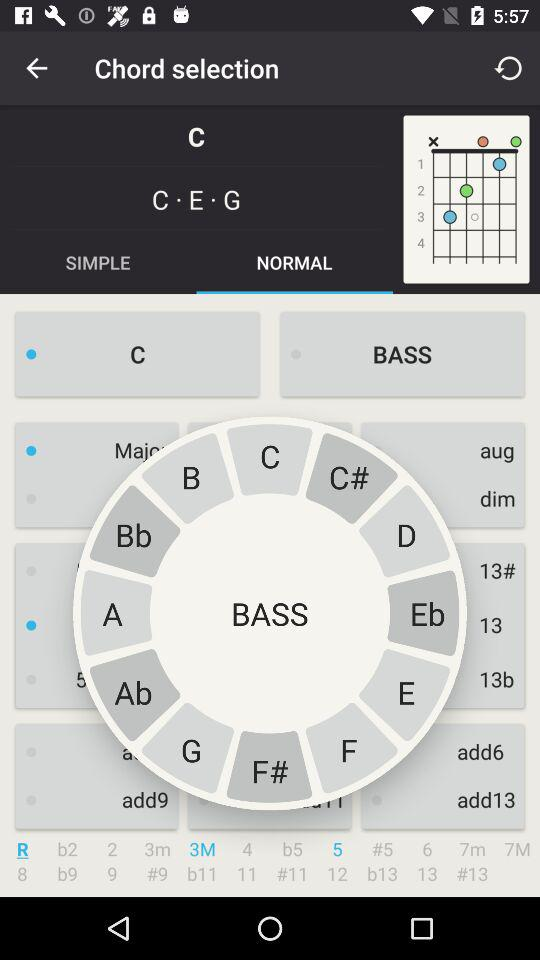Which type of chord is selected? The selected type of chord is "C". 